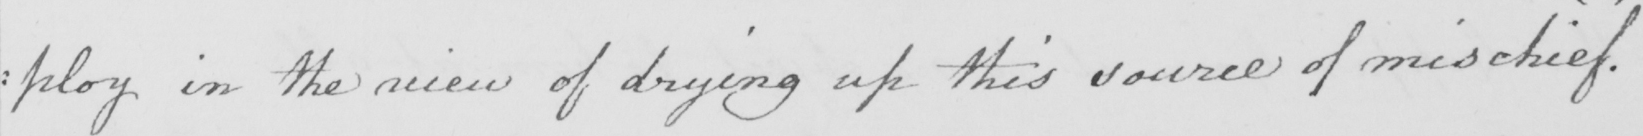Can you tell me what this handwritten text says? : ploy in the view of drying up this source of mischief . 